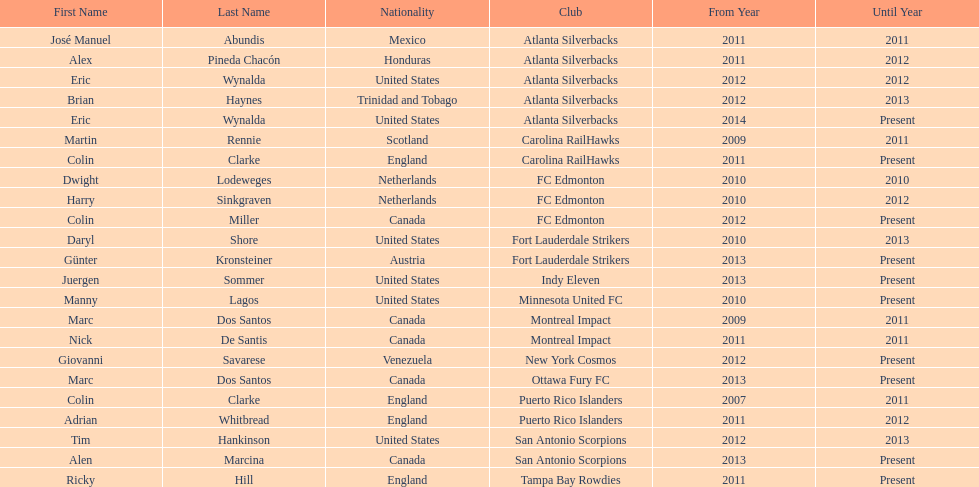How long did colin clarke coach the puerto rico islanders for? 4 years. 